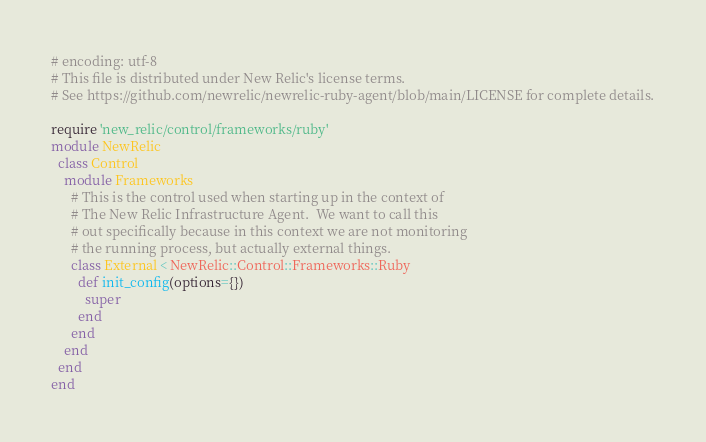Convert code to text. <code><loc_0><loc_0><loc_500><loc_500><_Ruby_># encoding: utf-8
# This file is distributed under New Relic's license terms.
# See https://github.com/newrelic/newrelic-ruby-agent/blob/main/LICENSE for complete details.

require 'new_relic/control/frameworks/ruby'
module NewRelic
  class Control
    module Frameworks
      # This is the control used when starting up in the context of
      # The New Relic Infrastructure Agent.  We want to call this
      # out specifically because in this context we are not monitoring
      # the running process, but actually external things.
      class External < NewRelic::Control::Frameworks::Ruby
        def init_config(options={})
          super
        end
      end
    end
  end
end
</code> 